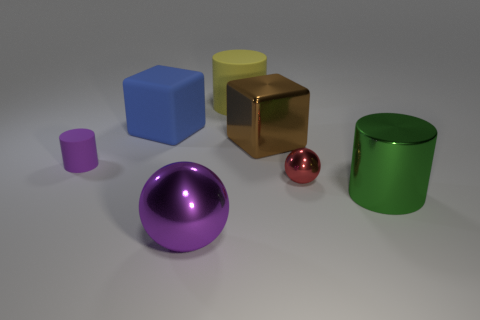Is the material of the large cylinder behind the blue matte cube the same as the small thing that is in front of the tiny cylinder?
Give a very brief answer. No. How big is the cylinder that is on the right side of the small rubber object and behind the small red metal object?
Your answer should be compact. Large. There is a red ball that is the same size as the purple rubber thing; what is it made of?
Keep it short and to the point. Metal. How many big purple things are behind the sphere that is behind the large purple sphere on the left side of the large brown cube?
Offer a terse response. 0. There is a big cylinder that is right of the yellow rubber cylinder; does it have the same color as the big block that is to the right of the large purple ball?
Your answer should be very brief. No. What is the color of the large thing that is in front of the tiny red metallic object and behind the purple ball?
Offer a very short reply. Green. What number of green cylinders are the same size as the blue thing?
Provide a short and direct response. 1. What is the shape of the big metal object on the right side of the large block that is right of the large blue block?
Provide a succinct answer. Cylinder. What is the shape of the big yellow matte object behind the shiny thing that is behind the ball that is on the right side of the metal block?
Offer a very short reply. Cylinder. How many other large things are the same shape as the big green shiny thing?
Offer a very short reply. 1. 